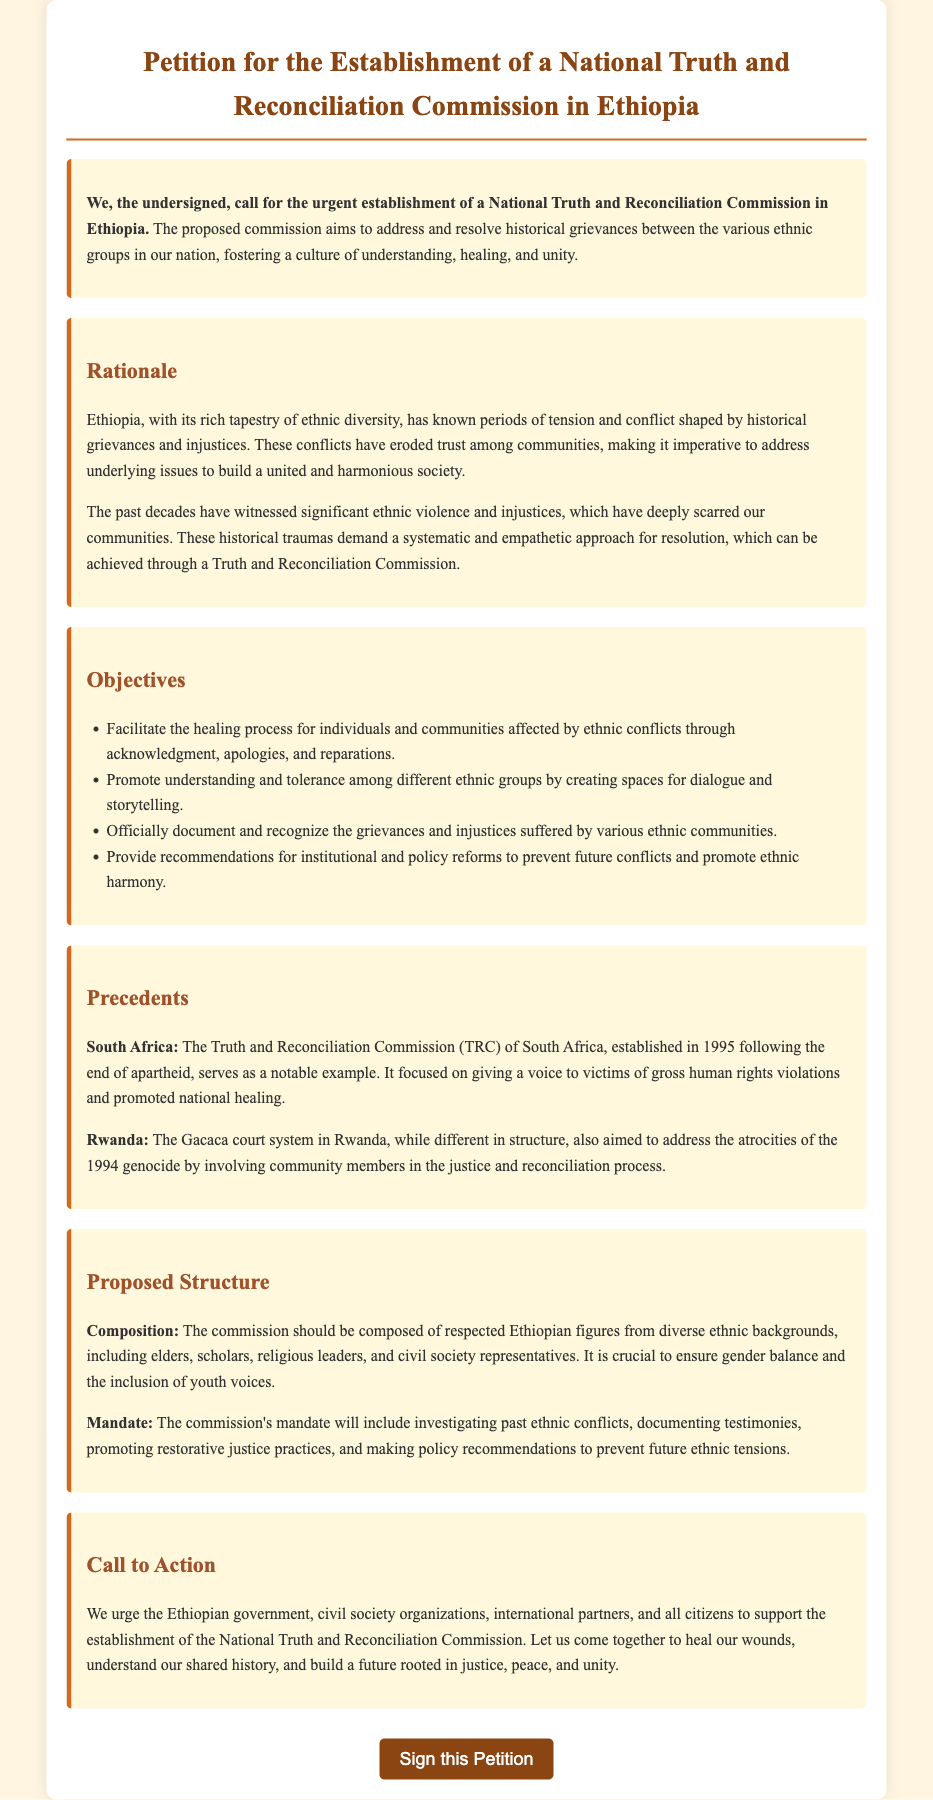What is the title of the document? The title of the document indicates the purpose of the petition and is explicitly stated at the top of the document.
Answer: Petition for the Establishment of a National Truth and Reconciliation Commission in Ethiopia What is the main aim of the proposed commission? The main aim is outlined in the introduction, focusing on addressing historical grievances between ethnic groups.
Answer: Fostering a culture of understanding, healing, and unity Who is encouraged to support the establishment of the commission? The call to action identifies several groups and individuals who are urged to support the establishment of the commission.
Answer: Ethiopian government, civil society organizations, international partners, and all citizens What notable example is given for a precedent related to truth and reconciliation? The document mentions examples to show the effectiveness of truth commissions in other countries.
Answer: South Africa What are two objectives of the National Truth and Reconciliation Commission? The objectives are listed in a bullet format, providing specific aims of the commission.
Answer: Facilitate the healing process; Promote understanding and tolerance What should the composition of the commission include? The proposed structure details the composition required for the commission, stressing diversity and representation.
Answer: Respected Ethiopian figures from diverse ethnic backgrounds What year was the Truth and Reconciliation Commission in South Africa established? The specific year is mentioned in the context of the precedent provided in the document.
Answer: 1995 What is a key component of the commission's mandate? The mandate details what the commission is meant to do, highlighting its investigative and documentation role.
Answer: Investigating past ethnic conflicts What approach does the petition advocate for resolving historical traumas? The rationale discusses the proposed method to address historical grievances and promotes a specific approach.
Answer: Systematic and empathetic approach What color is used for the call-to-action section? The visual details in the document provide information about the coloring scheme used throughout the different sections.
Answer: Background-color: #FFF8DC 